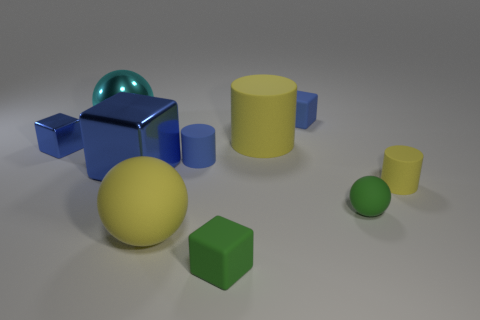Subtract all red cylinders. How many blue cubes are left? 3 Subtract all cubes. How many objects are left? 6 Add 8 cyan metallic objects. How many cyan metallic objects are left? 9 Add 7 big spheres. How many big spheres exist? 9 Subtract 0 brown blocks. How many objects are left? 10 Subtract all yellow cylinders. Subtract all tiny cylinders. How many objects are left? 6 